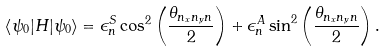<formula> <loc_0><loc_0><loc_500><loc_500>\left < \psi _ { 0 } | H | \psi _ { 0 } \right > = \epsilon _ { n } ^ { S } \cos ^ { 2 } \left ( \frac { \theta _ { n _ { x } n _ { y } n } } { 2 } \right ) + \epsilon _ { n } ^ { A } \sin ^ { 2 } \left ( \frac { \theta _ { n _ { x } n _ { y } n } } { 2 } \right ) .</formula> 